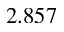Convert formula to latex. <formula><loc_0><loc_0><loc_500><loc_500>2 . 8 5 7</formula> 